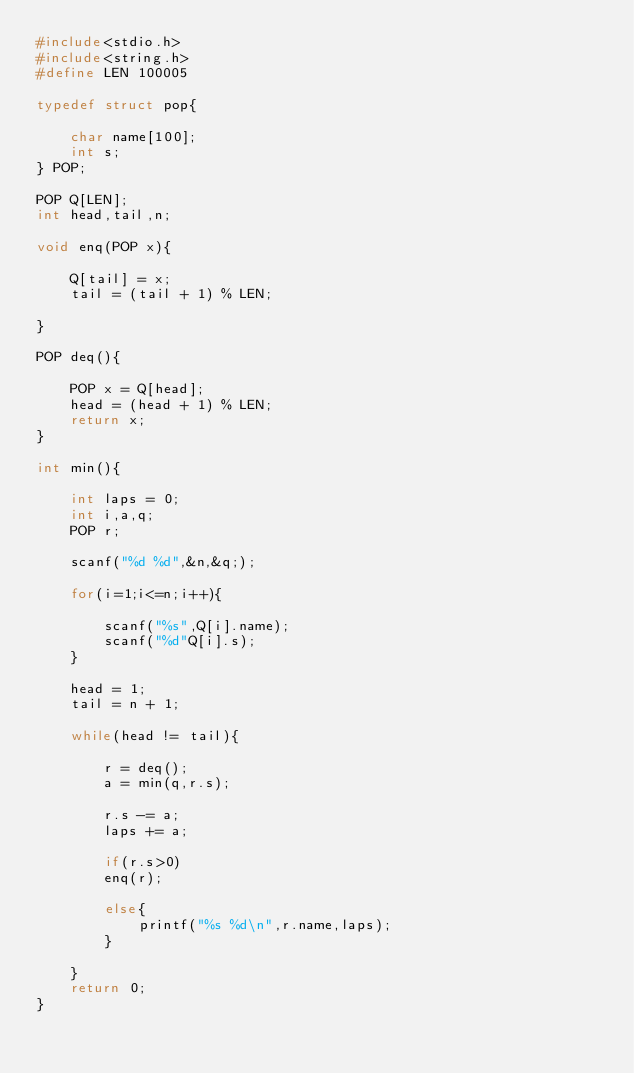Convert code to text. <code><loc_0><loc_0><loc_500><loc_500><_C_>#include<stdio.h>
#include<string.h>
#define LEN 100005

typedef struct pop{

    char name[100];
    int s;
} POP;

POP Q[LEN];
int head,tail,n;

void enq(POP x){

    Q[tail] = x;
    tail = (tail + 1) % LEN;

}

POP deq(){

    POP x = Q[head];
    head = (head + 1) % LEN;
    return x;
}

int min(){

    int laps = 0;
    int i,a,q;
    POP r;

    scanf("%d %d",&n,&q;);

    for(i=1;i<=n;i++){

        scanf("%s",Q[i].name);
        scanf("%d"Q[i].s);
    }

    head = 1;
    tail = n + 1;

    while(head != tail){

        r = deq();
        a = min(q,r.s);

        r.s -= a;
        laps += a;

        if(r.s>0)
        enq(r);

        else{
            printf("%s %d\n",r.name,laps);
        }

    }
    return 0;
}
</code> 